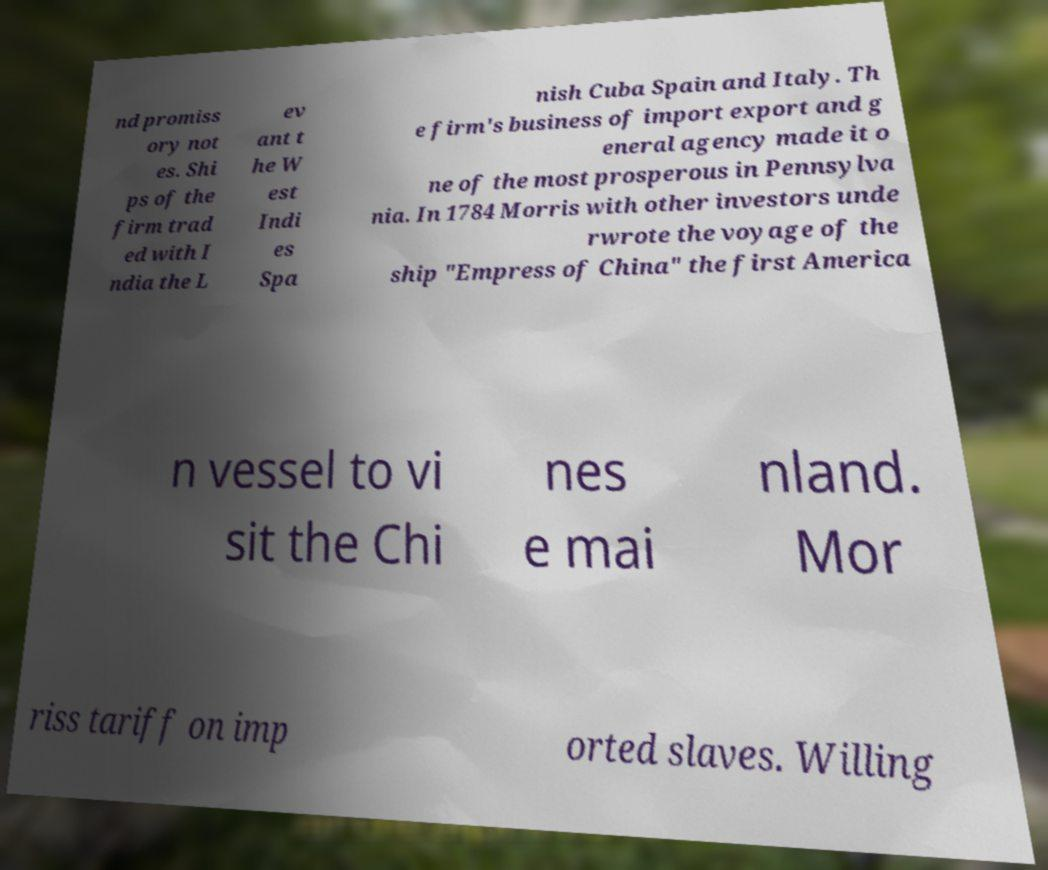Can you read and provide the text displayed in the image?This photo seems to have some interesting text. Can you extract and type it out for me? nd promiss ory not es. Shi ps of the firm trad ed with I ndia the L ev ant t he W est Indi es Spa nish Cuba Spain and Italy. Th e firm's business of import export and g eneral agency made it o ne of the most prosperous in Pennsylva nia. In 1784 Morris with other investors unde rwrote the voyage of the ship "Empress of China" the first America n vessel to vi sit the Chi nes e mai nland. Mor riss tariff on imp orted slaves. Willing 